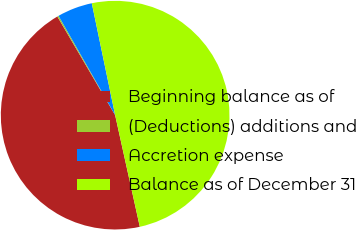Convert chart to OTSL. <chart><loc_0><loc_0><loc_500><loc_500><pie_chart><fcel>Beginning balance as of<fcel>(Deductions) additions and<fcel>Accretion expense<fcel>Balance as of December 31<nl><fcel>45.03%<fcel>0.19%<fcel>4.97%<fcel>49.81%<nl></chart> 